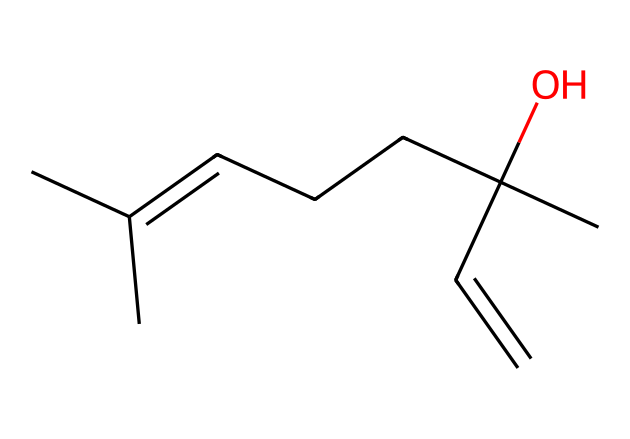What is the molecular formula of linalool? By analyzing the SMILES representation, we can count the number of carbon (C), hydrogen (H), and oxygen (O) atoms. The SMILES indicates 10 carbon atoms, 18 hydrogen atoms, and 1 oxygen atom, leading to the molecular formula C10H18O.
Answer: C10H18O How many rings are there in the structure of linalool? The SMILES does not indicate the presence of any rings, as there are no numbers denoting ring closure. Hence, it can be concluded that the structure is non-cyclic.
Answer: 0 What is the functional group present in linalool? The SMILES representation shows an -OH group, which signifies the presence of an alcohol functional group (due to the presence of the oxygen atom connected to a carbon and a hydrogen).
Answer: alcohol How many double bonds are present in linalool? To determine the number of double bonds, we can observe the connections in the structure. The SMILES indicates a double bond between two carbon atoms, representing one double bond.
Answer: 1 Is linalool an aromatic compound? Aromatic compounds typically contain a planar cyclic structure with conjugated pi bonds, which is not a feature of the structure described in the SMILES. Therefore, linalool does not fall into this category.
Answer: no What type of terpene is linalool based on its structure? Considering its structure and its functional group, linalool can be classified as a monoterpene because it consists of 10 carbon atoms derived from two isoprene units.
Answer: monoterpene What is the primary use of linalool? Linalool is widely recognized for its pleasant scent and is primarily used in perfumes and aromatherapy products, where its fragrance provides calming effects.
Answer: perfumes and aromatherapy 